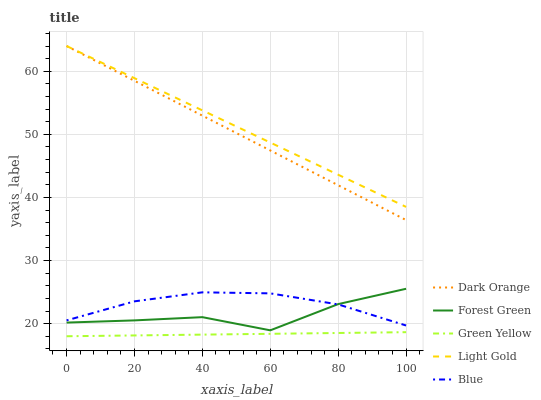Does Green Yellow have the minimum area under the curve?
Answer yes or no. Yes. Does Light Gold have the maximum area under the curve?
Answer yes or no. Yes. Does Dark Orange have the minimum area under the curve?
Answer yes or no. No. Does Dark Orange have the maximum area under the curve?
Answer yes or no. No. Is Dark Orange the smoothest?
Answer yes or no. Yes. Is Forest Green the roughest?
Answer yes or no. Yes. Is Forest Green the smoothest?
Answer yes or no. No. Is Dark Orange the roughest?
Answer yes or no. No. Does Dark Orange have the lowest value?
Answer yes or no. No. Does Forest Green have the highest value?
Answer yes or no. No. Is Green Yellow less than Blue?
Answer yes or no. Yes. Is Light Gold greater than Forest Green?
Answer yes or no. Yes. Does Green Yellow intersect Blue?
Answer yes or no. No. 